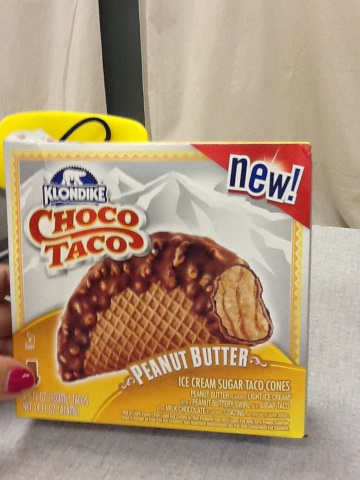Can you tell me more about the nutritional content of this product? Unfortunately, without clear visibility of the nutritional label, I can’t provide detailed information. However, generally, ice cream products like this might contain calories mainly from sugar and fats. 